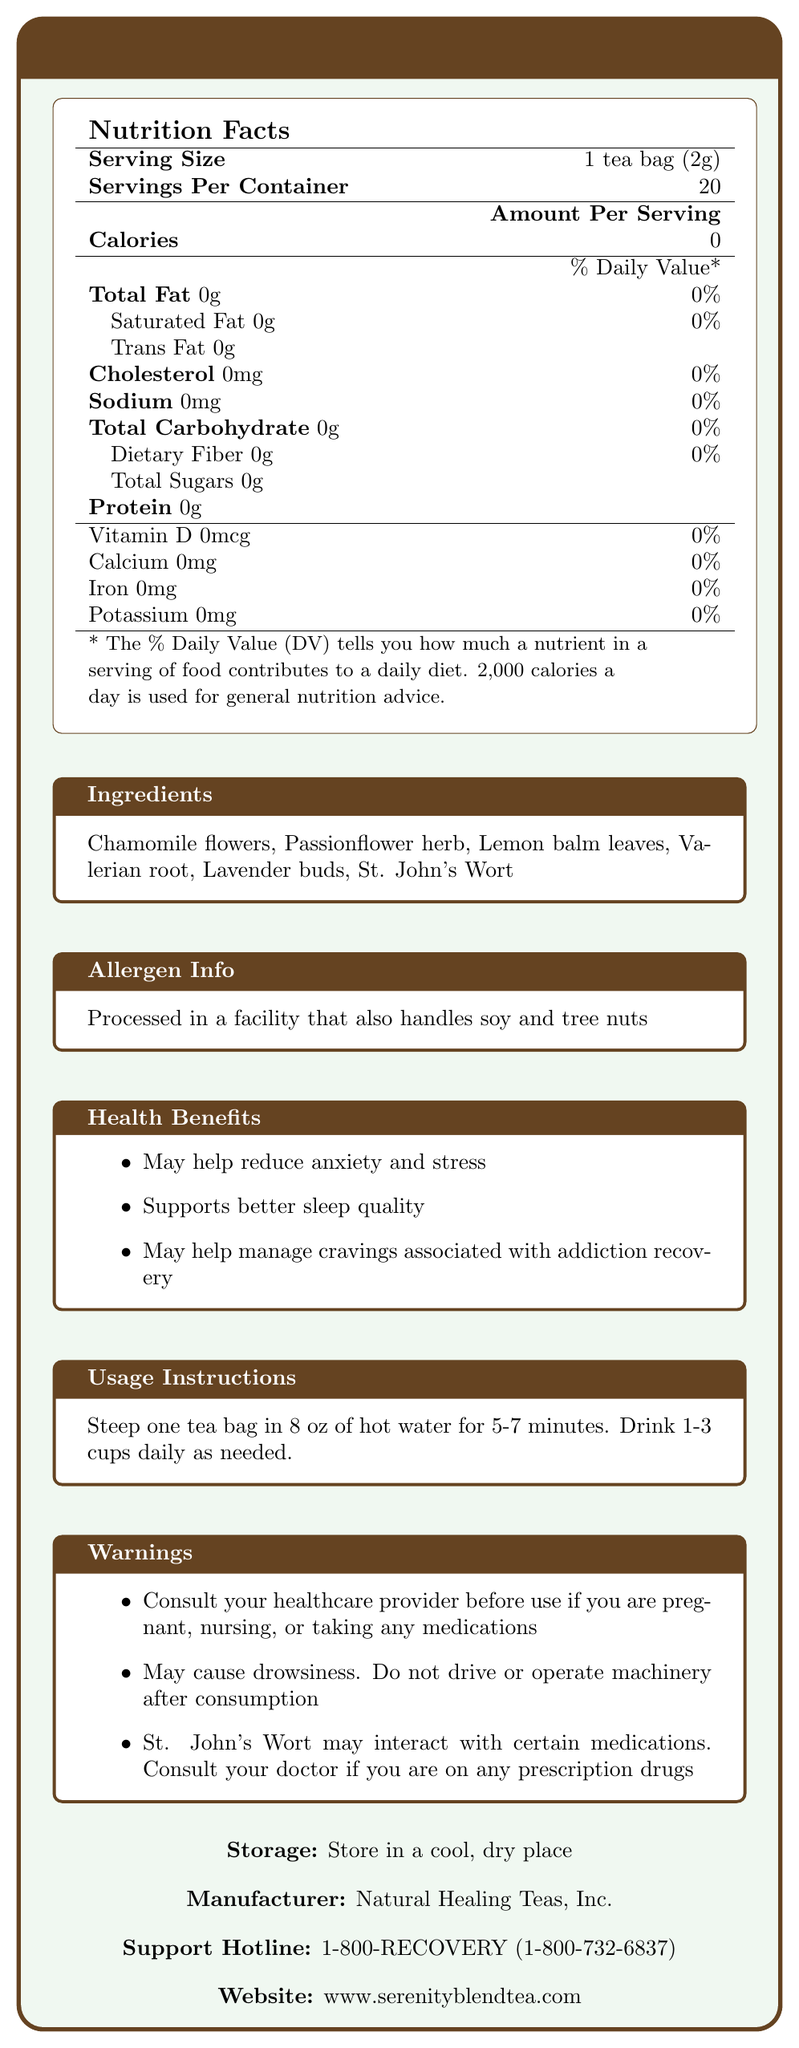what is the serving size of the Serenity Blend Herbal Tea? The serving size is clearly stated as 1 tea bag weighing 2 grams under the "Serving Size" section.
Answer: 1 tea bag (2g) how many servings are there per container? The document specifies that there are 20 servings per container under "Servings Per Container".
Answer: 20 does the Serenity Blend Herbal Tea contain any calories? (Yes/No) The Nutrition Facts section lists the calories as 0, indicating that the tea contains no calories.
Answer: No list two primary health benefits of the Serenity Blend Herbal Tea. Under the "Health Benefits" section, it mentions that the tea may help reduce anxiety and stress and supports better sleep quality.
Answer: May help reduce anxiety and stress, Supports better sleep quality which ingredient in the Serenity Blend Herbal Tea might interact with certain medications? The Warnings section indicates that St. John's Wort may interact with certain medications.
Answer: St. John's Wort what is the phone number listed for the support hotline? The support hotline number is given at the end of the document.
Answer: 1-800-RECOVERY (1-800-732-6837) who is the manufacturer of the Serenity Blend Herbal Tea? The manufacturer is listed at the end of the document.
Answer: Natural Healing Teas, Inc. what is the recommended daily consumption of Serenity Blend Herbal Tea? A. 1-2 cups B. 1-3 cups C. 2-3 cups D. 2-4 cups The Usage Instructions state to drink 1-3 cups daily as needed.
Answer: B which vitamins and minerals are present in the Serenity Blend Herbal Tea? A. Vitamin D B. Calcium C. Iron D. Potassium E. All of the above F. None of the above According to the Nutrition Facts, all of these nutrients (Vitamin D, Calcium, Iron, Potassium) are listed as 0%, so the correct answer is "None of the above".
Answer: F is it advisable to drive after consuming the Serenity Blend Herbal Tea? (Yes/No) The warnings section explicitly states that the tea may cause drowsiness and to avoid driving after consumption.
Answer: No briefly summarize the main purpose and content of the document. The document aims to present all relevant information about the herbal tea, emphasizing its zero-calorie content, beneficial ingredients, health advantages for anxiety and cravings management, and important safety guidelines.
Answer: The document provides detailed information about the Serenity Blend Herbal Tea, including its nutrition facts, ingredients, health benefits, usage instructions, allergen information, warnings, storage instructions, manufacturer details, and support hotline. what specific medications should be avoided when consuming Serenity Blend Herbal Tea? The document mentions St. John's Wort may interact with certain medications, but it does not specify which medications must be avoided.
Answer: Not enough information 